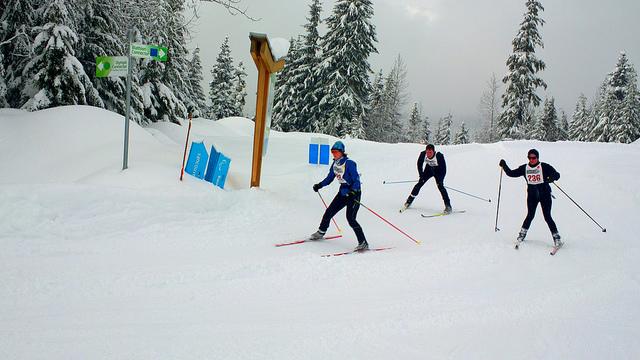Is the weather clear?
Short answer required. No. What are the skiers holding?
Short answer required. Poles. Are the skiers racing?
Write a very short answer. Yes. 